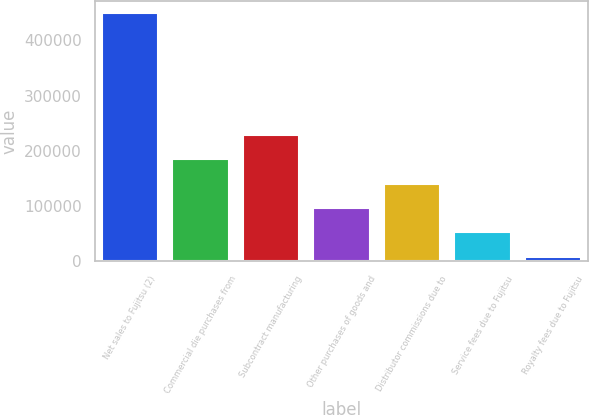Convert chart to OTSL. <chart><loc_0><loc_0><loc_500><loc_500><bar_chart><fcel>Net sales to Fujitsu (2)<fcel>Commercial die purchases from<fcel>Subcontract manufacturing<fcel>Other purchases of goods and<fcel>Distributor commissions due to<fcel>Service fees due to Fujitsu<fcel>Royalty fees due to Fujitsu<nl><fcel>448940<fcel>184779<fcel>228806<fcel>96725.6<fcel>140752<fcel>52698.8<fcel>8672<nl></chart> 